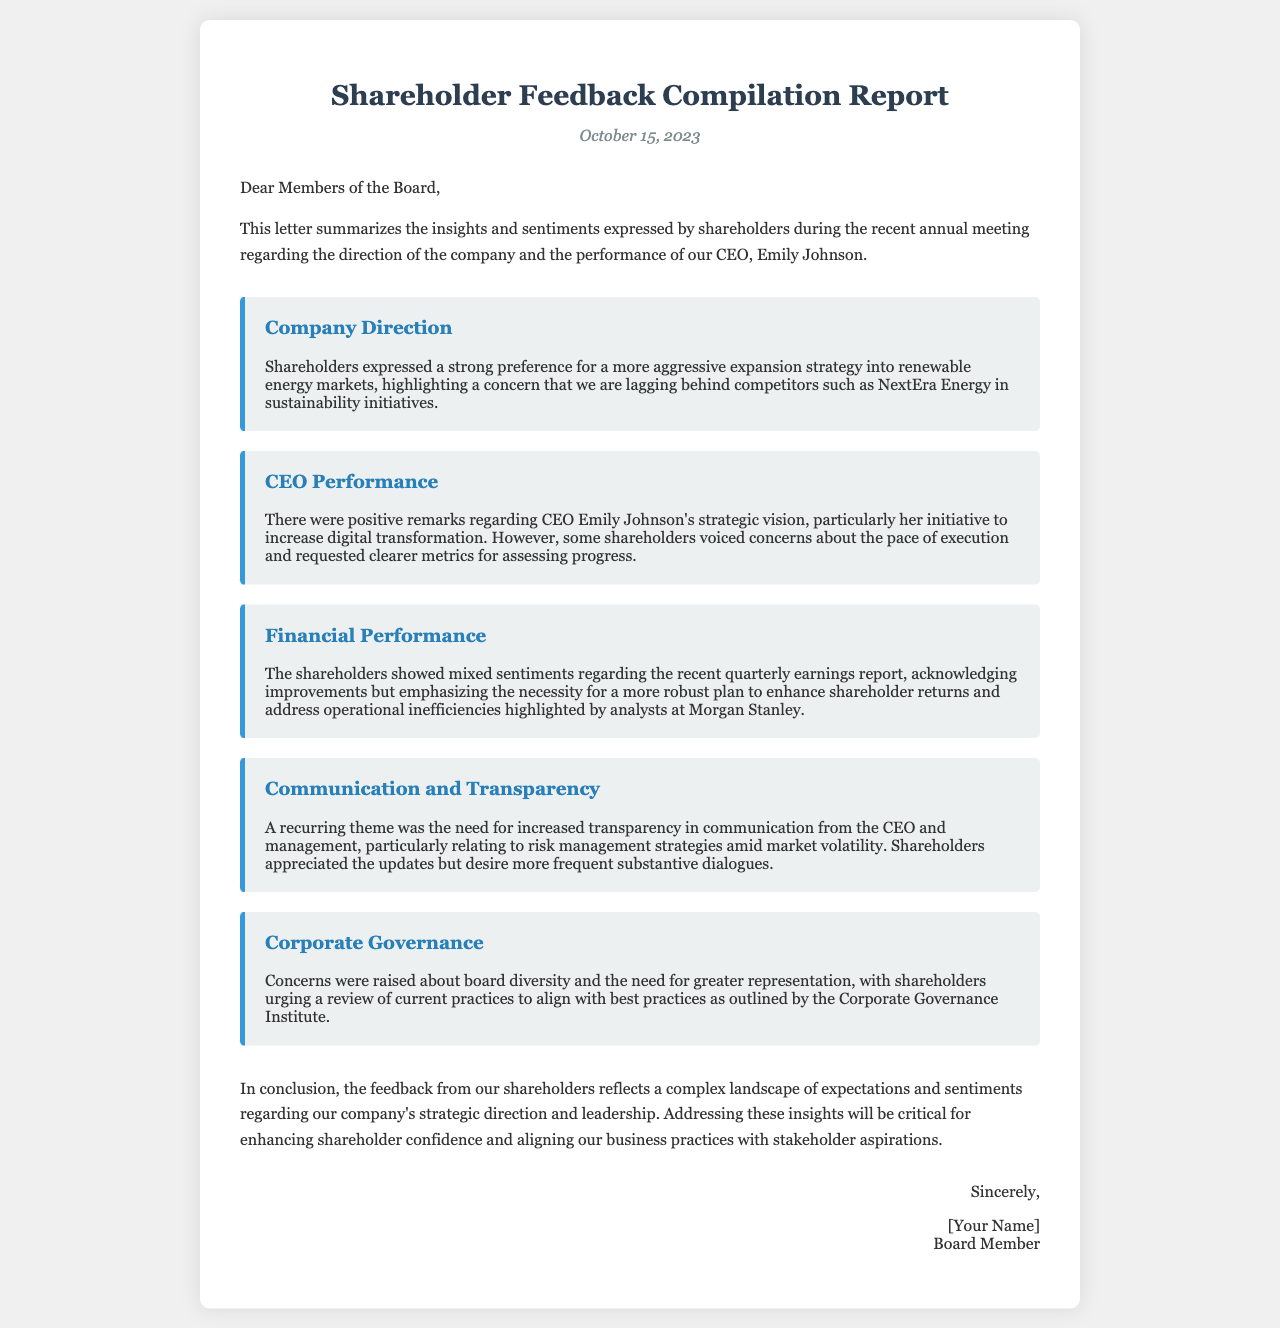What is the date of the report? The date of the report is mentioned at the top of the document.
Answer: October 15, 2023 Who is the CEO mentioned in the report? The report includes the name of the CEO who was discussed during the annual meeting.
Answer: Emily Johnson What key area of market expansion do shareholders want? The report indicates shareholders' preferences for specific market strategies.
Answer: Renewable energy markets What was a positive remark about the CEO's performance? The insights provided feedback on the CEO's initiatives, which is noted in the document.
Answer: Strategic vision What recurring theme was highlighted by shareholders concerning communication? The document discusses shareholders' views on management practices related to communication.
Answer: Increased transparency What financial aspect did shareholders express mixed sentiments about? The feedback covered opinions on recent financial performance, which is detailed in the document.
Answer: Quarterly earnings report What governance-related concern did shareholders raise? Shareholder feedback included discussions about governance practices that are mentioned in the report.
Answer: Board diversity What does the conclusion suggest about shareholder confidence? The conclusion reflects on the overall sentiments shared by shareholders about company operations.
Answer: Enhancing shareholder confidence 